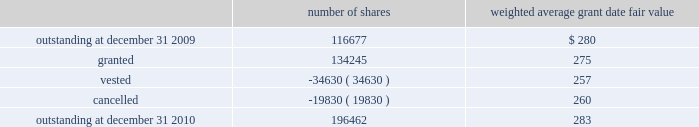The company granted 1020 performance shares .
The vesting of these shares is contingent on meeting stated goals over a performance period .
Beginning with restricted stock grants in september 2010 , dividends are accrued on restricted class a common stock and restricted stock units and are paid once the restricted stock vests .
The table summarizes restricted stock and performance shares activity for 2010 : number of shares weighted average grant date fair value .
The total fair value of restricted stock that vested during the years ended december 31 , 2010 , 2009 and 2008 , was $ 10.3 million , $ 6.2 million and $ 2.5 million , respectively .
Eligible employees may acquire shares of cme group 2019s class a common stock using after-tax payroll deductions made during consecutive offering periods of approximately six months in duration .
Shares are purchased at the end of each offering period at a price of 90% ( 90 % ) of the closing price of the class a common stock as reported on the nasdaq .
Compensation expense is recognized on the dates of purchase for the discount from the closing price .
In 2010 , 2009 and 2008 , a total of 4371 , 4402 and 5600 shares , respectively , of class a common stock were issued to participating employees .
These shares are subject to a six-month holding period .
Annual expense of $ 0.1 million for the purchase discount was recognized in 2010 , 2009 and 2008 , respectively .
Non-executive directors receive an annual award of class a common stock with a value equal to $ 75000 .
Non-executive directors may also elect to receive some or all of the cash portion of their annual stipend , up to $ 25000 , in shares of stock based on the closing price at the date of distribution .
As a result , 7470 , 11674 and 5509 shares of class a common stock were issued to non-executive directors during 2010 , 2009 and 2008 , respectively .
These shares are not subject to any vesting restrictions .
Expense of $ 2.4 million , $ 2.5 million and $ 2.4 million related to these stock-based payments was recognized for the years ended december 31 , 2010 , 2009 and 2008 , respectively. .
Based on the summary of the restricted stock and performance shares activity for 2010 what was percentage change in the number of shares outstanding? 
Computations: ((196462 - 116677) / 116677)
Answer: 0.68381. 